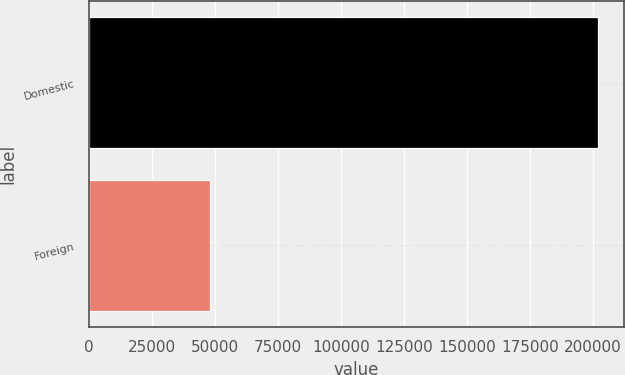Convert chart to OTSL. <chart><loc_0><loc_0><loc_500><loc_500><bar_chart><fcel>Domestic<fcel>Foreign<nl><fcel>202210<fcel>48006<nl></chart> 